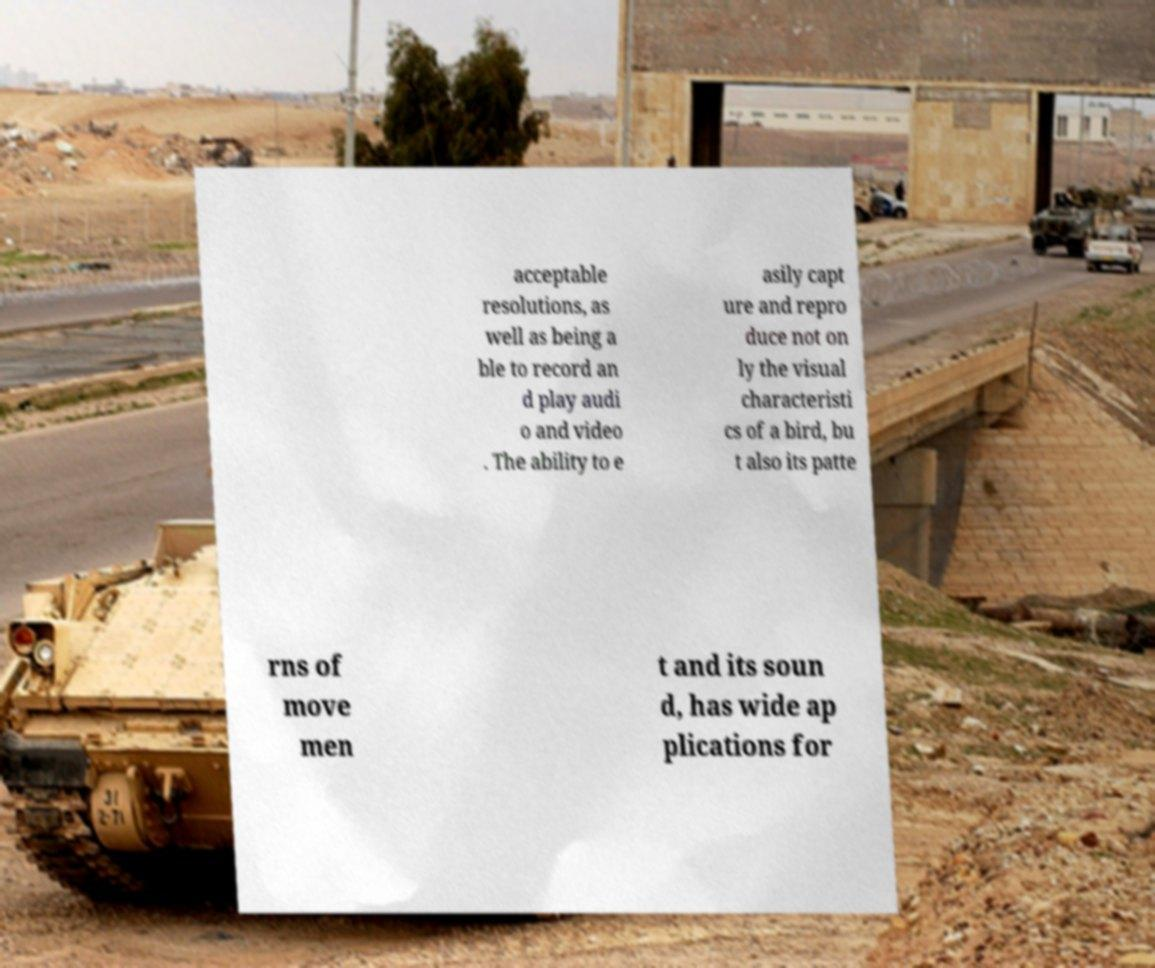Please read and relay the text visible in this image. What does it say? acceptable resolutions, as well as being a ble to record an d play audi o and video . The ability to e asily capt ure and repro duce not on ly the visual characteristi cs of a bird, bu t also its patte rns of move men t and its soun d, has wide ap plications for 